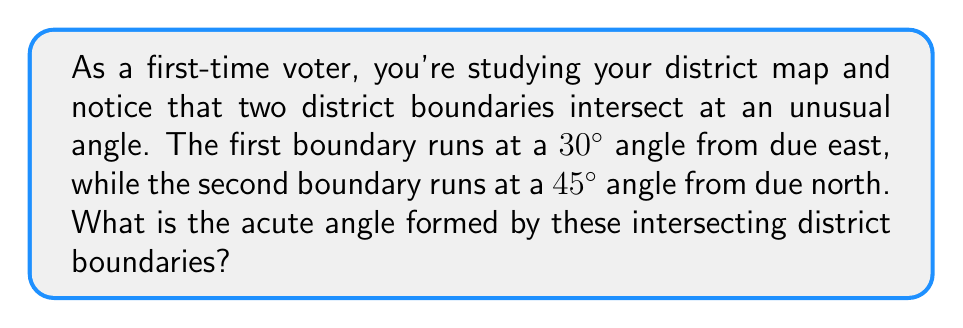What is the answer to this math problem? Let's approach this step-by-step:

1) First, we need to visualize the problem. Let's draw a diagram:

[asy]
import geometry;

size(200);
defaultpen(fontsize(10pt));

pair O=(0,0);
pair A=(3,0);
pair B=(3*cos(30*pi/180), 3*sin(30*pi/180));
pair C=(3*cos(45*pi/180), 3*sin(45*pi/180));

draw(O--A, arrow=Arrow(TeXHead));
draw(O--B, arrow=Arrow(TeXHead));
draw(O--C, arrow=Arrow(TeXHead));

label("East", A, E);
label("30°", (1.5,0.3));
label("45°", (1.5,1.5));
label("North", (0,3), N);
label("$\theta$", (0.5,0.5));

draw(arc(O,0.7,0,30), blue);
draw(arc(O,0.7,90,45), red);
[/asy]

2) The first boundary is at a 30° angle from due east, which means it's at a $90° - 30° = 60°$ angle from due north.

3) The second boundary is at a 45° angle from due north.

4) To find the angle between these boundaries, we need to subtract the smaller angle from the larger:

   $\theta = 60° - 45° = 15°$

5) However, the question asks for the acute angle. The acute angle will always be the smaller of the two angles formed by intersecting lines. In this case, 15° is already the acute angle, so no further calculation is needed.
Answer: 15° 